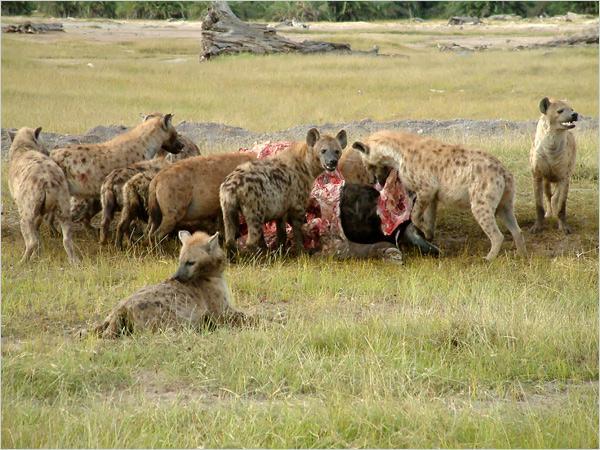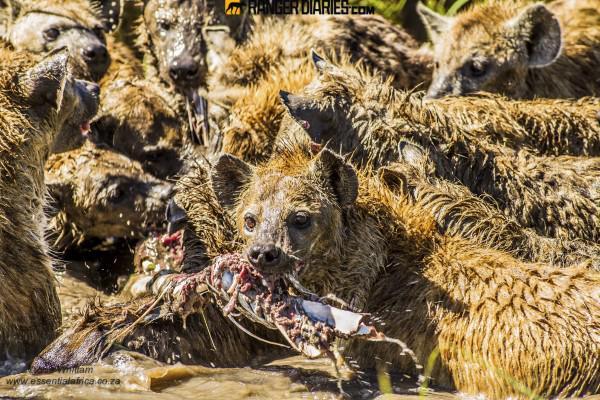The first image is the image on the left, the second image is the image on the right. For the images shown, is this caption "Some of the animals are eating their prey." true? Answer yes or no. Yes. The first image is the image on the left, the second image is the image on the right. Examine the images to the left and right. Is the description "At least one of the images shows hyenas eating a carcass." accurate? Answer yes or no. Yes. 